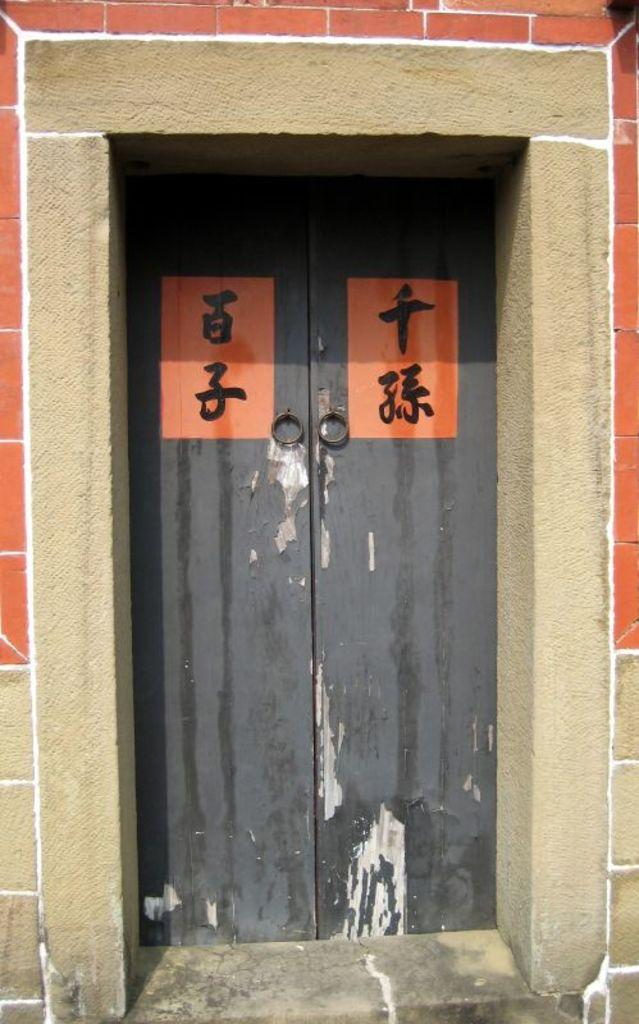What color are the doors in the image? The doors in the image are black. What additional color can be seen on the doors? The doors have orange color paint on them. What is written or drawn on the orange paint? There is text on the orange paint. What type of background can be seen behind the doors? There is a stone wall in the image. What type of creature is holding a wrench in the image? There is no creature holding a wrench in the image; it only features black doors with orange paint and text. What is inside the jar that is visible in the image? There is no jar present in the image. 